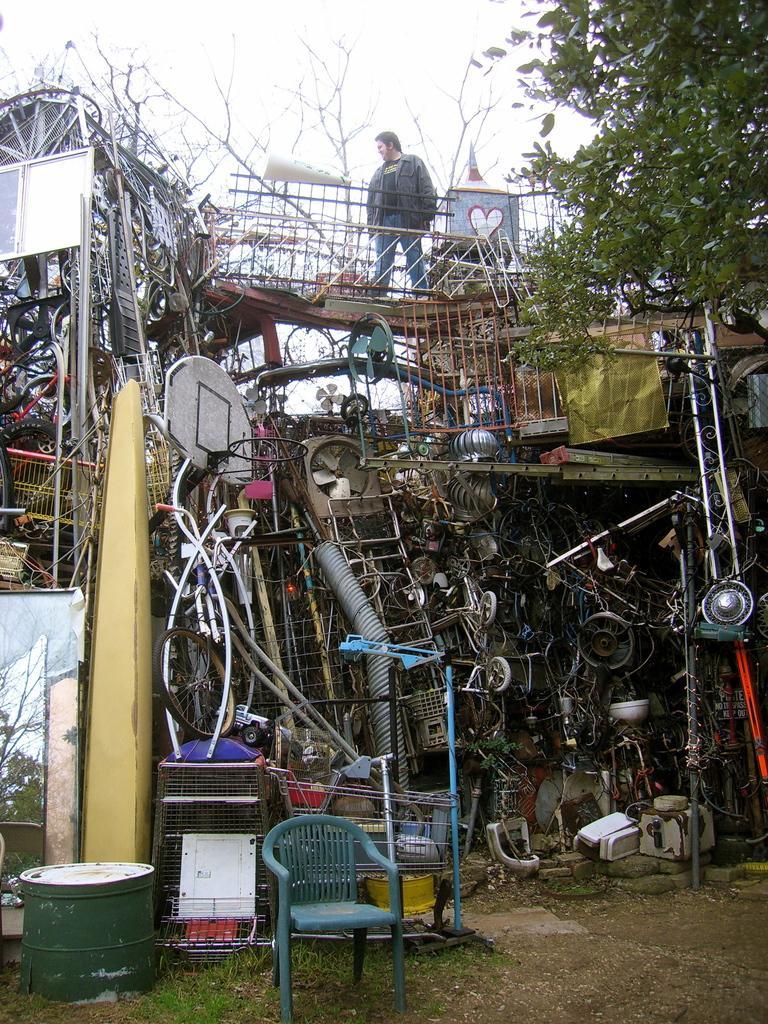Please provide a concise description of this image. In this image, we can see a chair and there is some metal scrap, we can see a person standing and there is a tree, at the top there is a sky. 